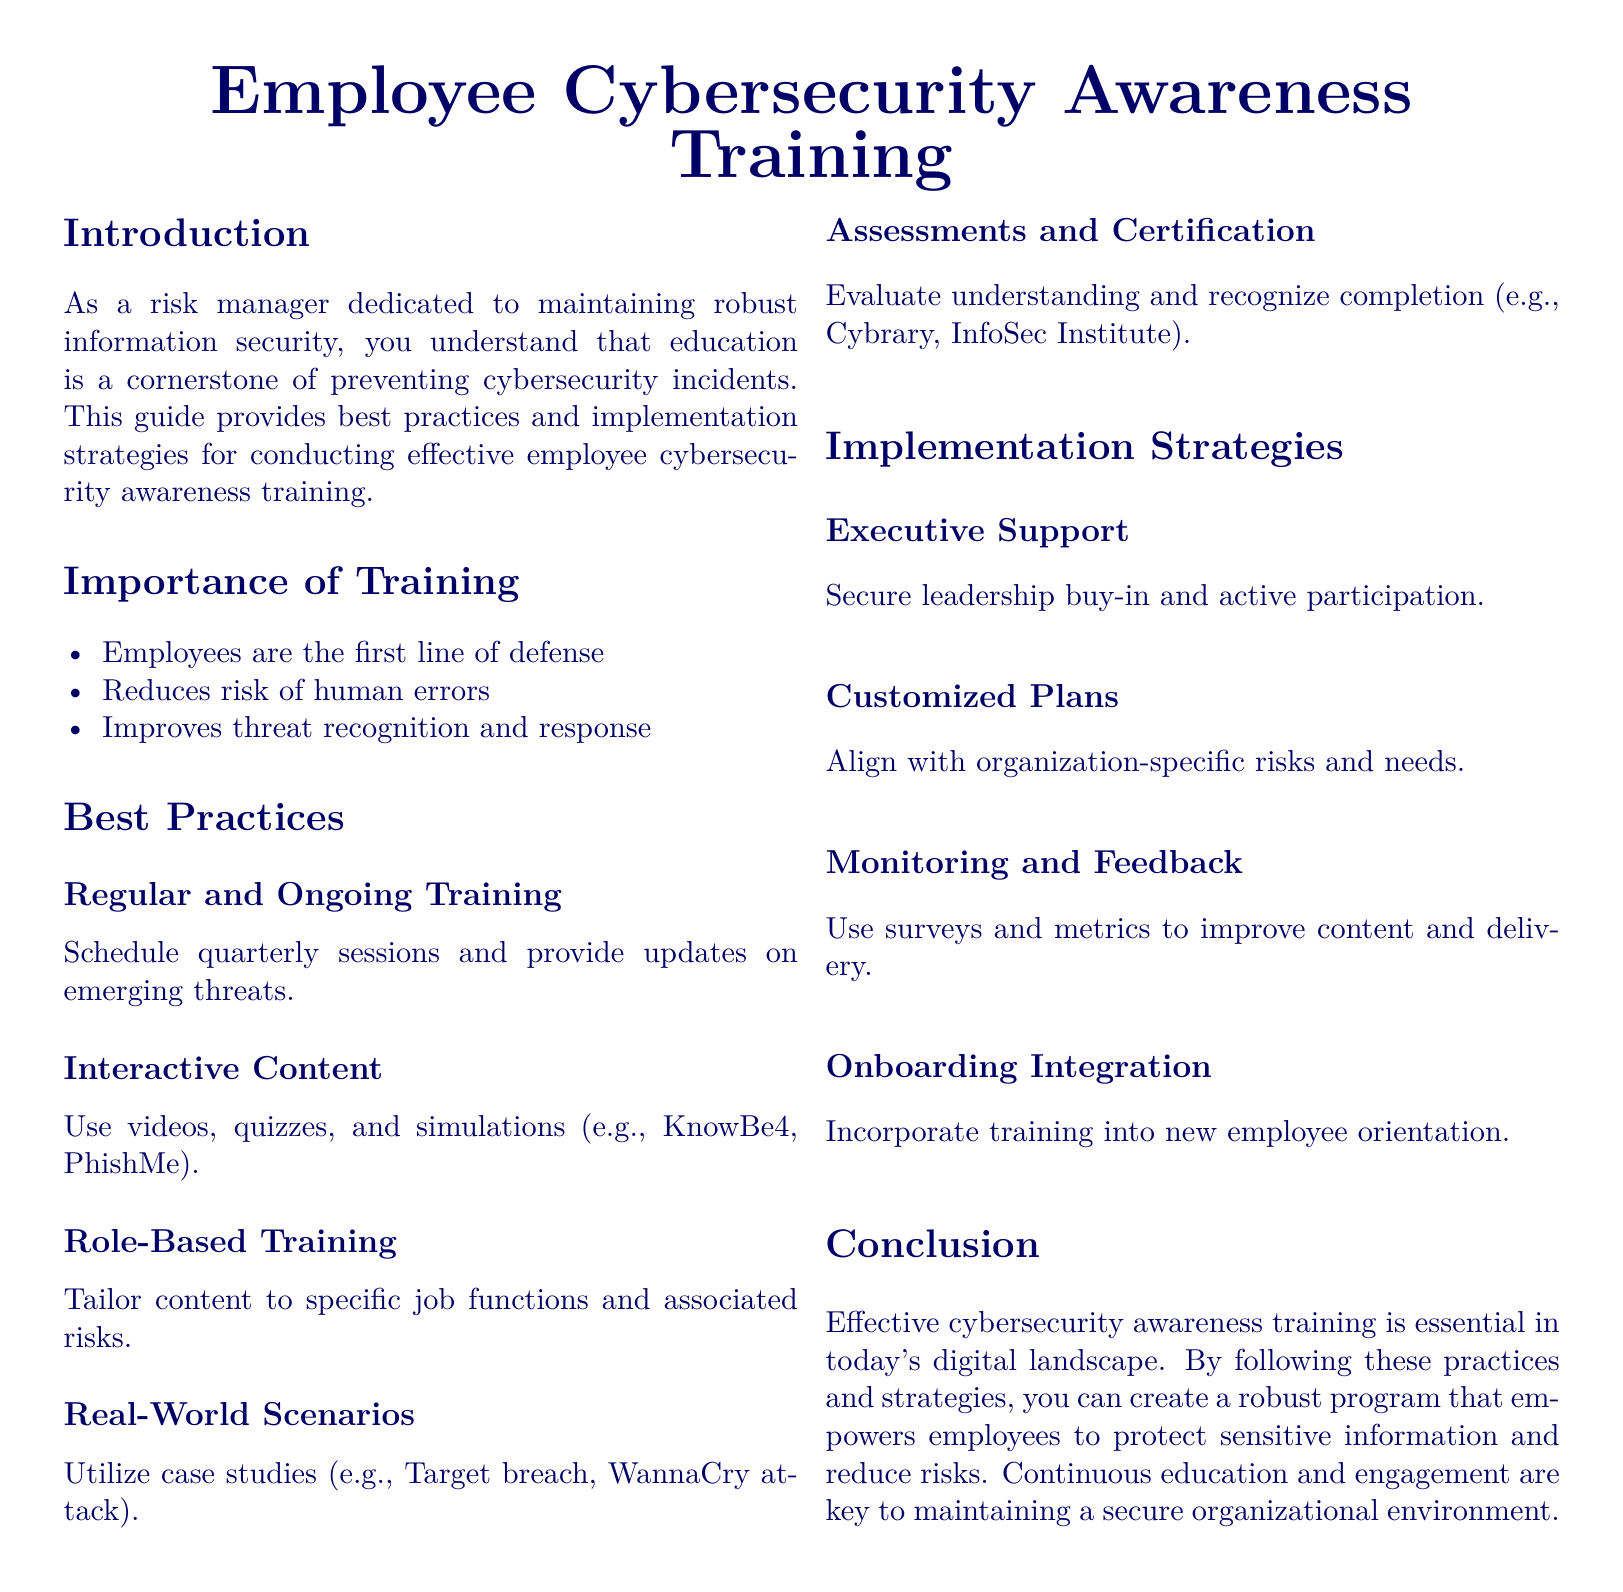What is the main focus of the guide? The main focus of the guide is to provide best practices and implementation strategies for conducting effective employee cybersecurity awareness training.
Answer: Employee cybersecurity awareness training How often should training sessions be scheduled? The document suggests scheduling training sessions quarterly to keep employees updated on emerging threats.
Answer: Quarterly What kind of content should be included in training? The guide recommends using interactive content such as videos, quizzes, and simulations.
Answer: Interactive content What should training content be tailored to? According to the guide, training content should be tailored to specific job functions and associated risks.
Answer: Job functions What kind of support is crucial for training implementation? The document highlights the necessity of securing executive support and active participation for effective training implementation.
Answer: Executive support How can employee understanding be evaluated? Evaluating understanding can be done through assessments and certification after the training sessions.
Answer: Assessments and certification What should be included in new employee orientation? The guide advises incorporating cybersecurity awareness training into the onboarding process of new employees.
Answer: Cybersecurity awareness training What is a key aspect of maintaining a secure organizational environment? The guide emphasizes that continuous education and engagement are key aspects of maintaining a secure environment.
Answer: Continuous education and engagement 